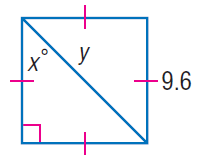Answer the mathemtical geometry problem and directly provide the correct option letter.
Question: Find y.
Choices: A: 4.8 B: 4.8 \sqrt { 2 } C: 9.6 D: 9.6 \sqrt { 2 } D 